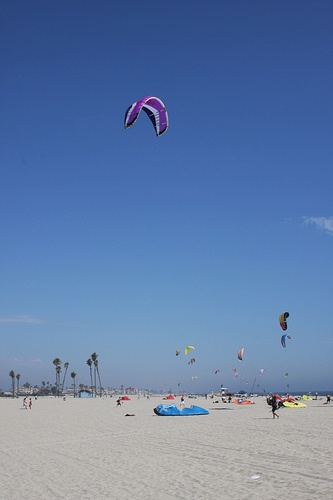Describe the objects in this image and their specific colors. I can see kite in darkblue, purple, black, and gray tones, kite in darkblue, gray, blue, lightblue, and black tones, boat in darkblue, gray, blue, lightblue, and black tones, kite in darkblue and gray tones, and kite in darkblue, black, gray, and darkgray tones in this image. 